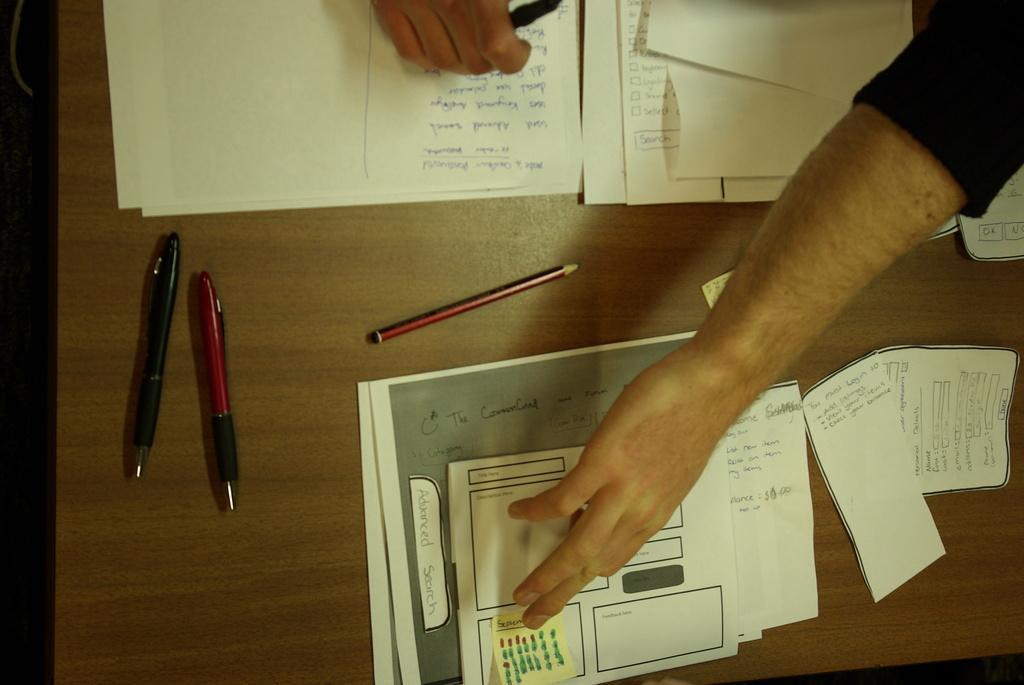Describe this image in one or two sentences. In this image we can see papers, pencil and pens on a table. We can also see hand of a person and fingers of another person. 